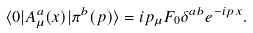<formula> <loc_0><loc_0><loc_500><loc_500>\langle 0 | A _ { \mu } ^ { a } ( x ) | \pi ^ { b } ( p ) \rangle = i p _ { \mu } F _ { 0 } \delta ^ { a b } e ^ { - i p x } .</formula> 